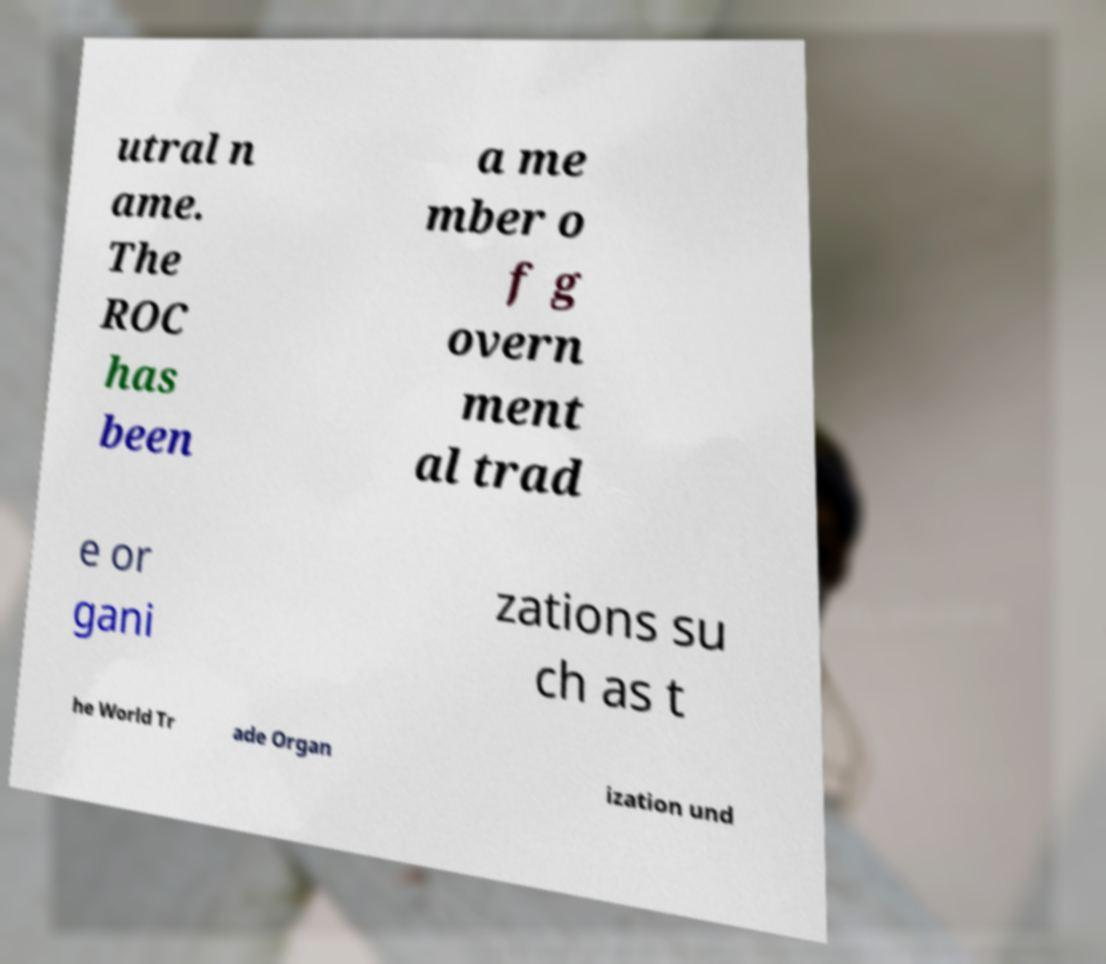Please read and relay the text visible in this image. What does it say? utral n ame. The ROC has been a me mber o f g overn ment al trad e or gani zations su ch as t he World Tr ade Organ ization und 